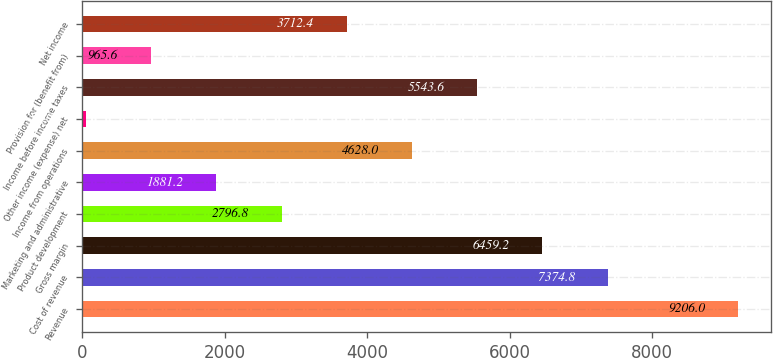Convert chart to OTSL. <chart><loc_0><loc_0><loc_500><loc_500><bar_chart><fcel>Revenue<fcel>Cost of revenue<fcel>Gross margin<fcel>Product development<fcel>Marketing and administrative<fcel>Income from operations<fcel>Other income (expense) net<fcel>Income before income taxes<fcel>Provision for (benefit from)<fcel>Net income<nl><fcel>9206<fcel>7374.8<fcel>6459.2<fcel>2796.8<fcel>1881.2<fcel>4628<fcel>50<fcel>5543.6<fcel>965.6<fcel>3712.4<nl></chart> 